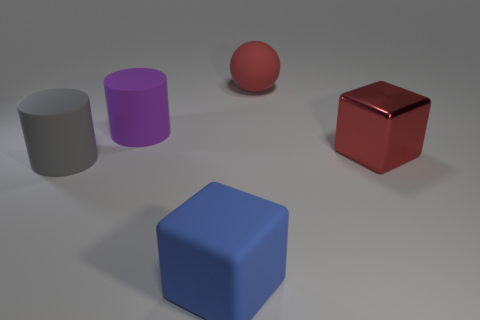Is there any other thing that has the same material as the large red cube?
Your answer should be very brief. No. How many other things are the same size as the blue object?
Give a very brief answer. 4. There is a big thing that is in front of the gray object; what is its material?
Provide a succinct answer. Rubber. There is a red object that is behind the big red thing that is right of the rubber thing on the right side of the matte cube; what is its shape?
Your response must be concise. Sphere. How many things are either large matte things or big rubber objects to the left of the large blue thing?
Offer a very short reply. 4. How many things are blue cubes that are right of the big purple cylinder or big metal blocks on the right side of the large purple matte cylinder?
Your answer should be compact. 2. Are there any matte cylinders behind the rubber block?
Make the answer very short. Yes. What is the color of the block that is to the left of the big red object that is in front of the large matte thing to the right of the matte cube?
Give a very brief answer. Blue. Does the large blue object have the same shape as the big red rubber object?
Provide a succinct answer. No. There is a big ball that is the same material as the gray object; what is its color?
Your answer should be compact. Red. 